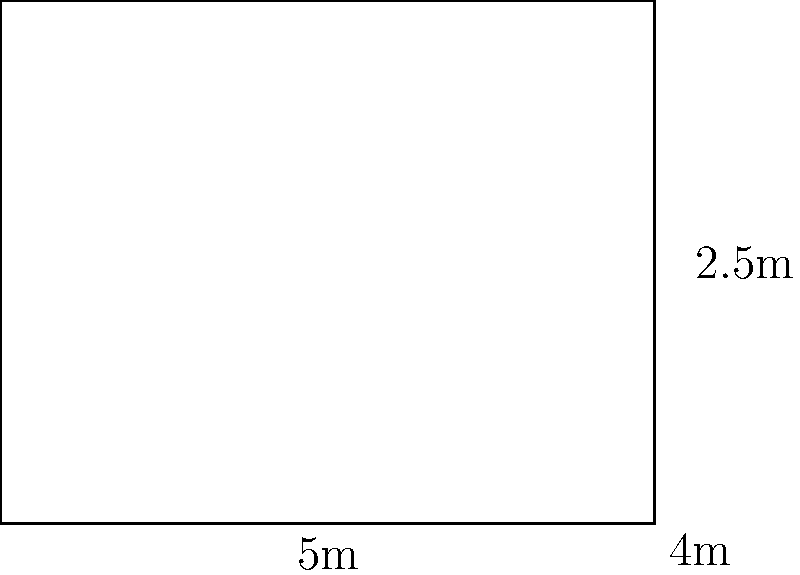As a property manager, you need to estimate the amount of paint required for a tenant's apartment. The room diagram shows a rectangular space with dimensions 5m x 4m and a ceiling height of 2.5m. There is one standard door (2m x 0.8m) and one window (1m x 1m). If one liter of paint covers 10 square meters, how many liters of paint are needed to cover all walls, excluding the door and window areas? Round your answer to the nearest tenth. Let's break this down step-by-step:

1) Calculate the total wall area:
   - Perimeter of the room: $2(5m + 4m) = 18m$
   - Wall area: $18m \times 2.5m = 45m^2$

2) Calculate the area to be subtracted:
   - Door area: $2m \times 0.8m = 1.6m^2$
   - Window area: $1m \times 1m = 1m^2$
   - Total area to subtract: $1.6m^2 + 1m^2 = 2.6m^2$

3) Calculate the net area to be painted:
   $45m^2 - 2.6m^2 = 42.4m^2$

4) Calculate the amount of paint needed:
   - Paint coverage: 10 $m^2$ per liter
   - Paint needed: $42.4m^2 \div 10m^2/L = 4.24L$

5) Round to the nearest tenth:
   $4.24L \approx 4.2L$
Answer: 4.2 liters 